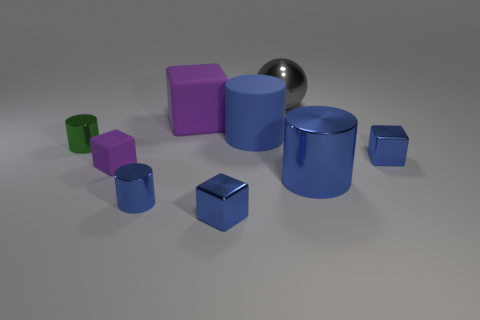What number of other objects are there of the same shape as the small green metal object?
Make the answer very short. 3. What material is the big gray thing behind the big cylinder right of the ball?
Make the answer very short. Metal. What shape is the green metallic object?
Provide a short and direct response. Cylinder. Are there the same number of tiny purple objects in front of the big purple thing and blue matte cylinders behind the big rubber cylinder?
Provide a short and direct response. No. There is a metallic block that is left of the blue matte thing; does it have the same color as the big metallic object to the right of the large ball?
Keep it short and to the point. Yes. Are there more blue objects that are to the left of the large blue rubber cylinder than small green shiny things?
Offer a terse response. Yes. What shape is the big blue object that is the same material as the green object?
Ensure brevity in your answer.  Cylinder. There is a purple rubber thing behind the green metal cylinder; is it the same size as the big blue matte object?
Your answer should be compact. Yes. There is a tiny blue shiny object that is right of the gray metal ball behind the big purple matte block; what shape is it?
Offer a very short reply. Cube. How big is the purple rubber block in front of the block that is on the right side of the blue matte thing?
Provide a short and direct response. Small. 